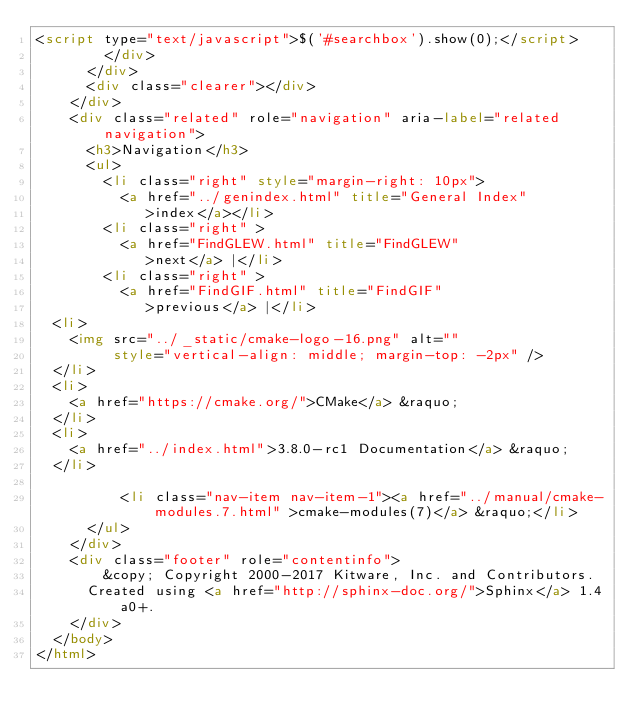<code> <loc_0><loc_0><loc_500><loc_500><_HTML_><script type="text/javascript">$('#searchbox').show(0);</script>
        </div>
      </div>
      <div class="clearer"></div>
    </div>
    <div class="related" role="navigation" aria-label="related navigation">
      <h3>Navigation</h3>
      <ul>
        <li class="right" style="margin-right: 10px">
          <a href="../genindex.html" title="General Index"
             >index</a></li>
        <li class="right" >
          <a href="FindGLEW.html" title="FindGLEW"
             >next</a> |</li>
        <li class="right" >
          <a href="FindGIF.html" title="FindGIF"
             >previous</a> |</li>
  <li>
    <img src="../_static/cmake-logo-16.png" alt=""
         style="vertical-align: middle; margin-top: -2px" />
  </li>
  <li>
    <a href="https://cmake.org/">CMake</a> &raquo;
  </li>
  <li>
    <a href="../index.html">3.8.0-rc1 Documentation</a> &raquo;
  </li>

          <li class="nav-item nav-item-1"><a href="../manual/cmake-modules.7.html" >cmake-modules(7)</a> &raquo;</li> 
      </ul>
    </div>
    <div class="footer" role="contentinfo">
        &copy; Copyright 2000-2017 Kitware, Inc. and Contributors.
      Created using <a href="http://sphinx-doc.org/">Sphinx</a> 1.4a0+.
    </div>
  </body>
</html></code> 